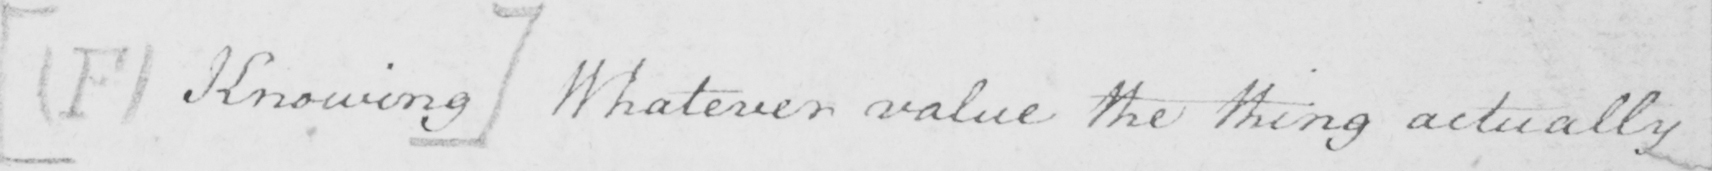Please provide the text content of this handwritten line. [  ( F ) Knowing ]  Whatever value the thing actually 